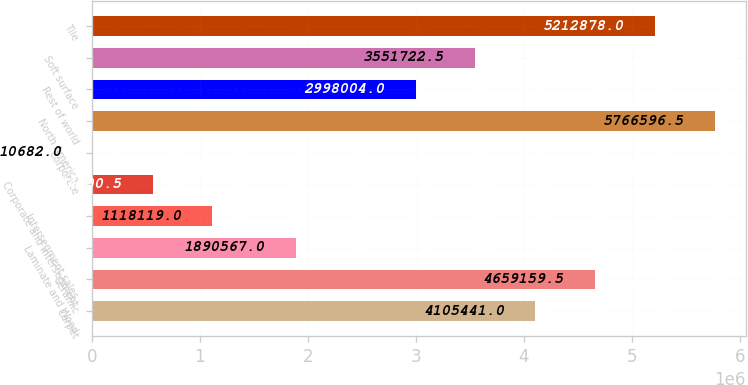<chart> <loc_0><loc_0><loc_500><loc_500><bar_chart><fcel>Carpet<fcel>Ceramic<fcel>Laminate and Wood<fcel>Intersegment sales<fcel>Corporate and intersegment<fcel>Corporate<fcel>North America<fcel>Rest of world<fcel>Soft surface<fcel>Tile<nl><fcel>4.10544e+06<fcel>4.65916e+06<fcel>1.89057e+06<fcel>1.11812e+06<fcel>564400<fcel>10682<fcel>5.7666e+06<fcel>2.998e+06<fcel>3.55172e+06<fcel>5.21288e+06<nl></chart> 